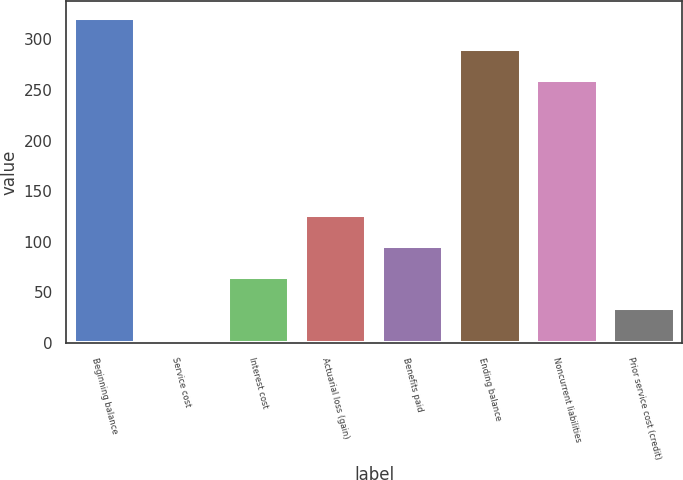Convert chart. <chart><loc_0><loc_0><loc_500><loc_500><bar_chart><fcel>Beginning balance<fcel>Service cost<fcel>Interest cost<fcel>Actuarial loss (gain)<fcel>Benefits paid<fcel>Ending balance<fcel>Noncurrent liabilities<fcel>Prior service cost (credit)<nl><fcel>321.4<fcel>4<fcel>65.4<fcel>126.8<fcel>96.1<fcel>290.7<fcel>260<fcel>34.7<nl></chart> 